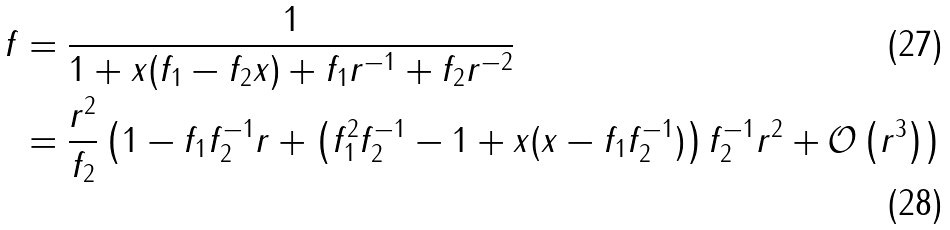Convert formula to latex. <formula><loc_0><loc_0><loc_500><loc_500>f & = \frac { 1 } { 1 + x ( f _ { 1 } - f _ { 2 } x ) + f _ { 1 } r ^ { - 1 } + f _ { 2 } r ^ { - 2 } } \\ & = \frac { r ^ { 2 } } { f _ { 2 } } \left ( 1 - f _ { 1 } f _ { 2 } ^ { - 1 } r + \left ( f _ { 1 } ^ { 2 } f _ { 2 } ^ { - 1 } - 1 + x ( x - f _ { 1 } f _ { 2 } ^ { - 1 } ) \right ) f _ { 2 } ^ { - 1 } r ^ { 2 } + \mathcal { O } \left ( r ^ { 3 } \right ) \right )</formula> 